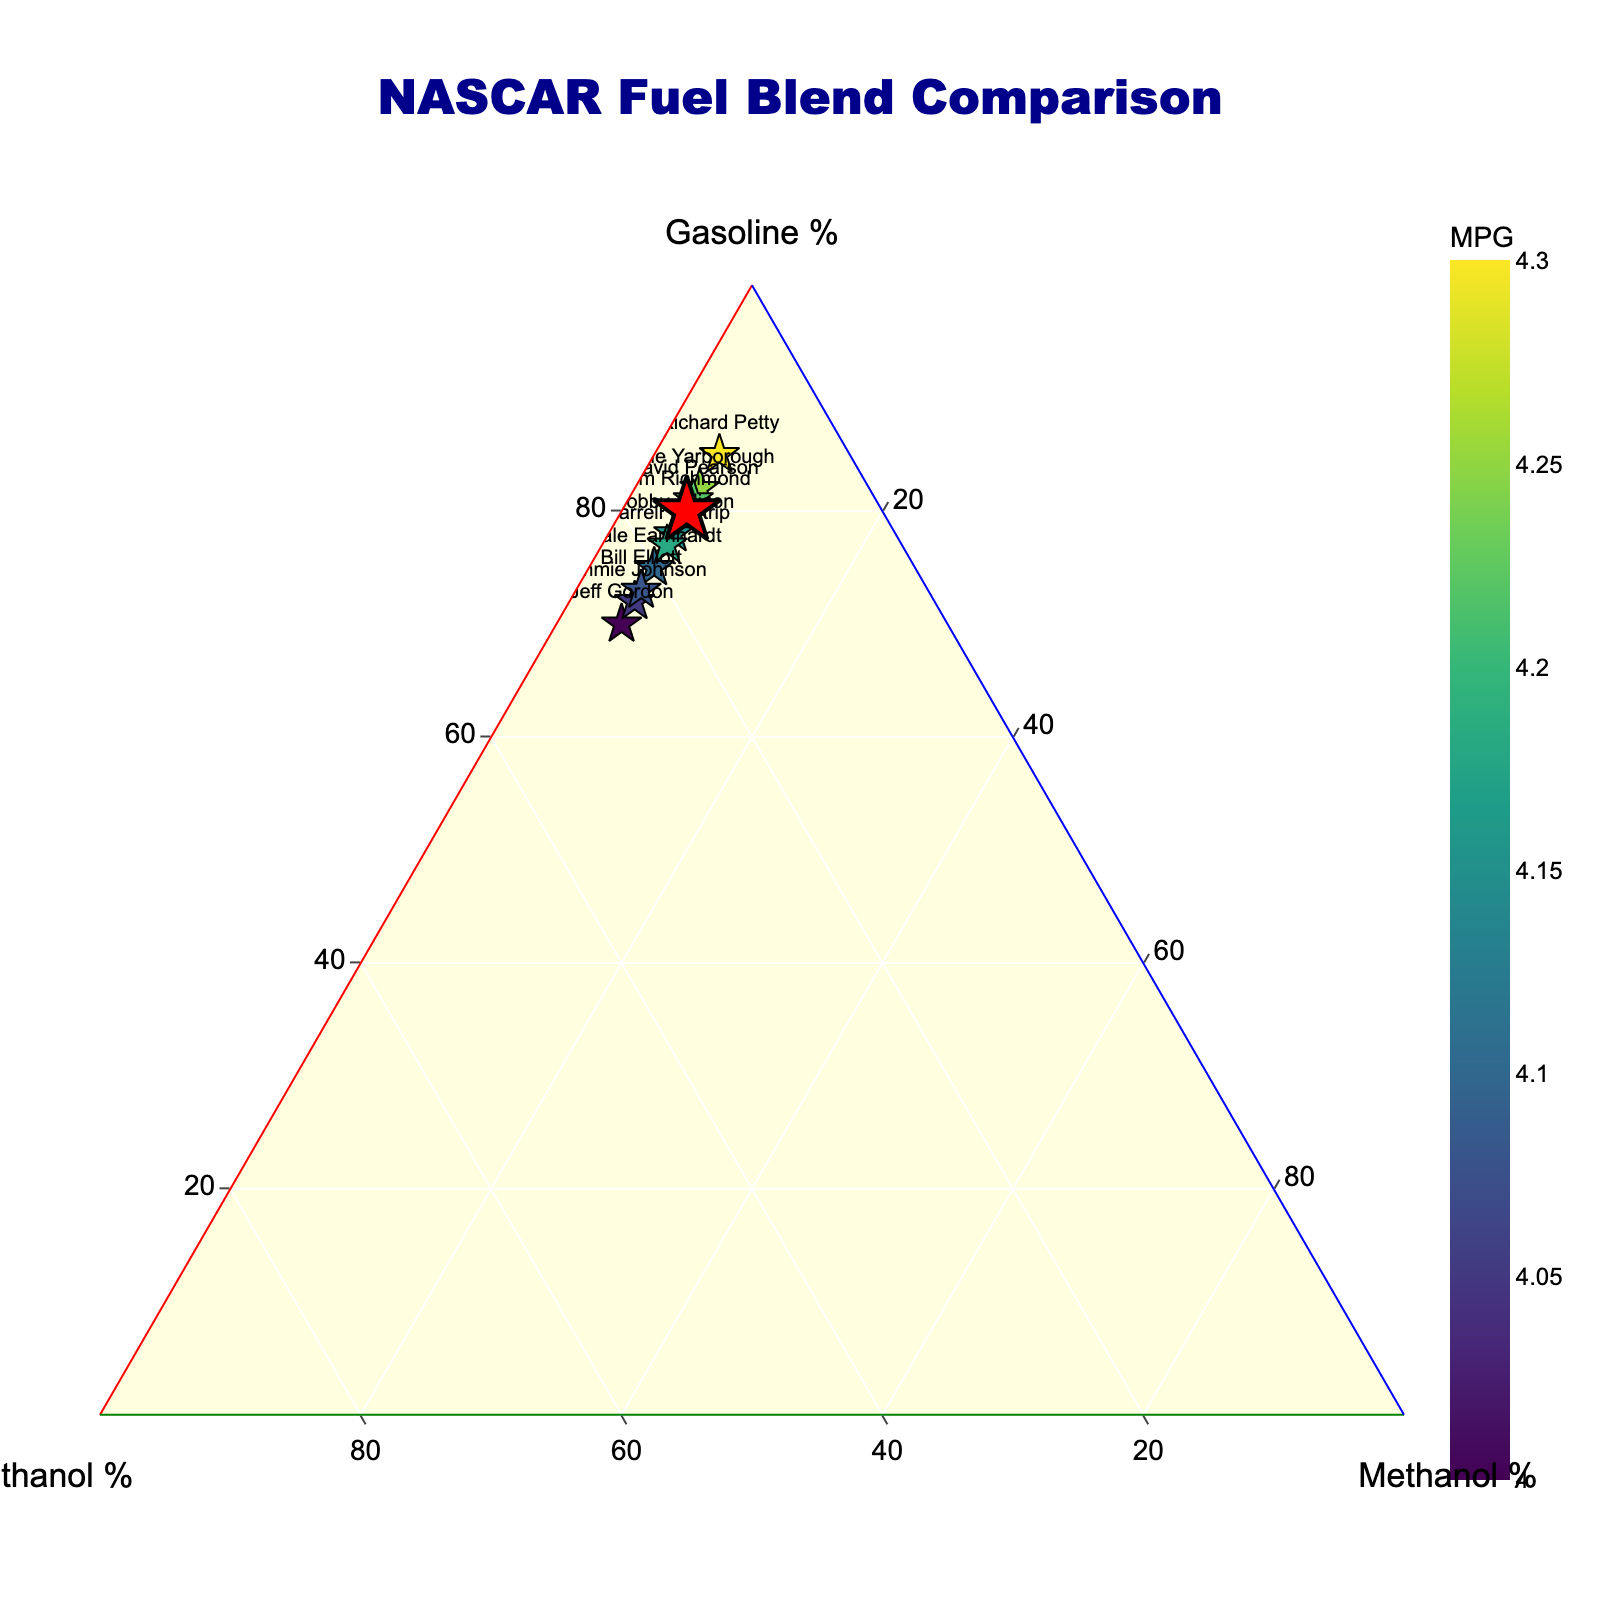Which fuel blend uses the highest percentage of ethanol? By observing the labels next to each marker on the plot, we can see that Jeff Gordon’s blend (Gordon Mix) uses the highest percentage of ethanol at 25%.
Answer: Gordon Mix What is the title of the plot? The title of the plot is displayed at the top center and reads "NASCAR Fuel Blend Comparison".
Answer: NASCAR Fuel Blend Comparison Which driver’s blend has the highest MPG? The color scale and MPG annotations indicate that Richard Petty’s blend (Petty Powerhouse) has the highest MPG at 4.3.
Answer: Petty Powerhouse How much gasoline does Tim Richmond’s blend contain? By locating Tim Richmond's marked data point, which is highlighted in red, on the ternary plot, we can see it contains 80% gasoline.
Answer: 80% What is the difference in ethanol percentage between Earnhardt Blend and Waltrip Wonder? According to the positions and accompanying data labels, Earnhardt Blend contains 20% ethanol and Waltrip Wonder contains 18% ethanol. The difference is 20% - 18% = 2%.
Answer: 2% Which fuel blend has the lowest MPG, and what is its gasoline percentage? The color scale and MPG annotations indicate that Jeff Gordon’s blend (Gordon Mix) has the lowest MPG at 4.0. By referring to the gas percentage, it has 70% gasoline.
Answer: Gordon Mix, 70% Compare Tim Richmond’s blend with David Pearson’s blend in terms of gasoline and methanol percentages. Tim Richmond’s blend (Richmond Special) contains 80% gasoline and 5% methanol. David Pearson’s blend (Pearson Performance) contains 81% gasoline and 5% methanol. Comparison: Pearson Performance has 1% more gasoline, and both have the same methanol percentage.
Answer: Pearson Performance has 1% more gasoline, same methanol Consider the blend named “Yarborough Yield.” What is the sum of its percentages of gasoline and ethanol? According to the data labels, Yarborough Yield contains 82% gasoline and 13% ethanol. The sum of these percentages is 82% + 13% = 95%.
Answer: 95% Which blend has exactly 5% methanol and also displays the MPG value of 4.25? By observing the ternary plot and annotations, Cale Yarborough’s blend (Yarborough Yield) contains 5% methanol and has an MPG value of 4.25.
Answer: Yarborough Yield 